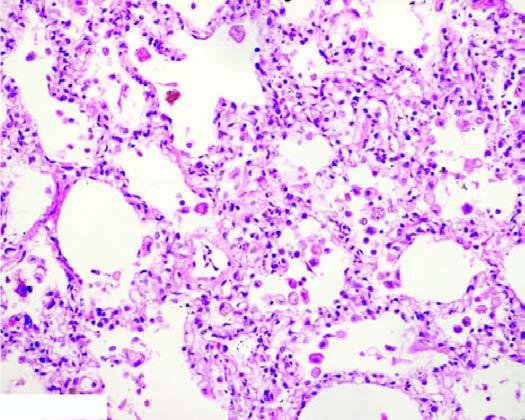re the interstitial vasculature widened and thickened due to congestion, oedema and mild fibrosis?
Answer the question using a single word or phrase. No 